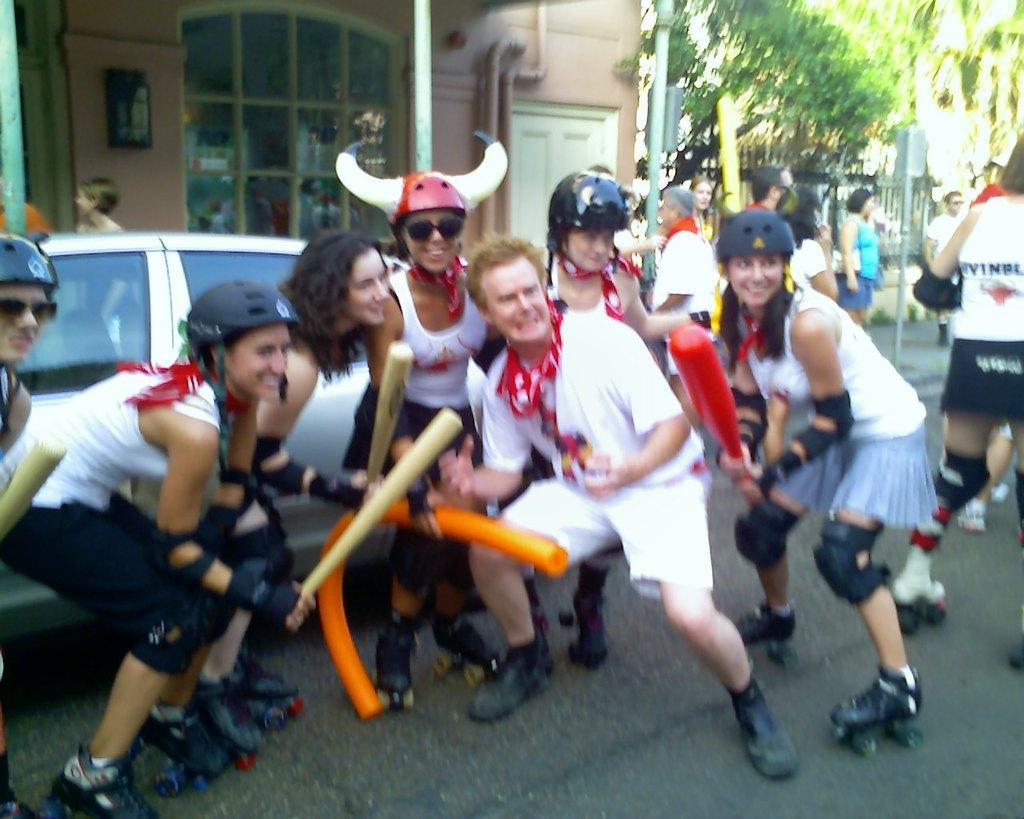Could you give a brief overview of what you see in this image? In this image, at the middle there is a man standing, there are some people standing on the skateboards and they are wearing helmets, at the background there is a car and there is a house, there are some people walking, there are some green color trees. 